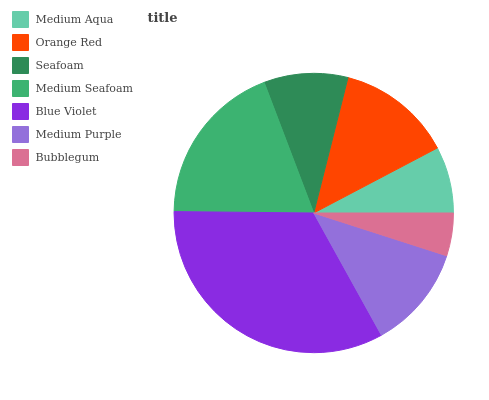Is Bubblegum the minimum?
Answer yes or no. Yes. Is Blue Violet the maximum?
Answer yes or no. Yes. Is Orange Red the minimum?
Answer yes or no. No. Is Orange Red the maximum?
Answer yes or no. No. Is Orange Red greater than Medium Aqua?
Answer yes or no. Yes. Is Medium Aqua less than Orange Red?
Answer yes or no. Yes. Is Medium Aqua greater than Orange Red?
Answer yes or no. No. Is Orange Red less than Medium Aqua?
Answer yes or no. No. Is Medium Purple the high median?
Answer yes or no. Yes. Is Medium Purple the low median?
Answer yes or no. Yes. Is Medium Seafoam the high median?
Answer yes or no. No. Is Blue Violet the low median?
Answer yes or no. No. 